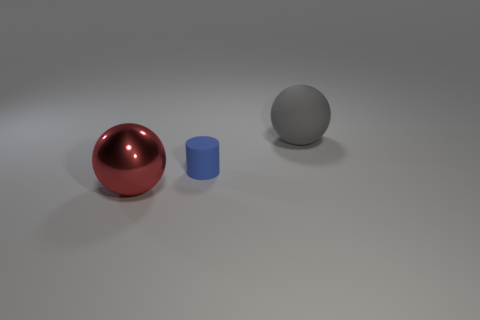Add 1 yellow rubber cylinders. How many objects exist? 4 Subtract all cylinders. How many objects are left? 2 Add 2 small blue objects. How many small blue objects are left? 3 Add 3 blue cylinders. How many blue cylinders exist? 4 Subtract 0 yellow blocks. How many objects are left? 3 Subtract all gray matte things. Subtract all tiny blue things. How many objects are left? 1 